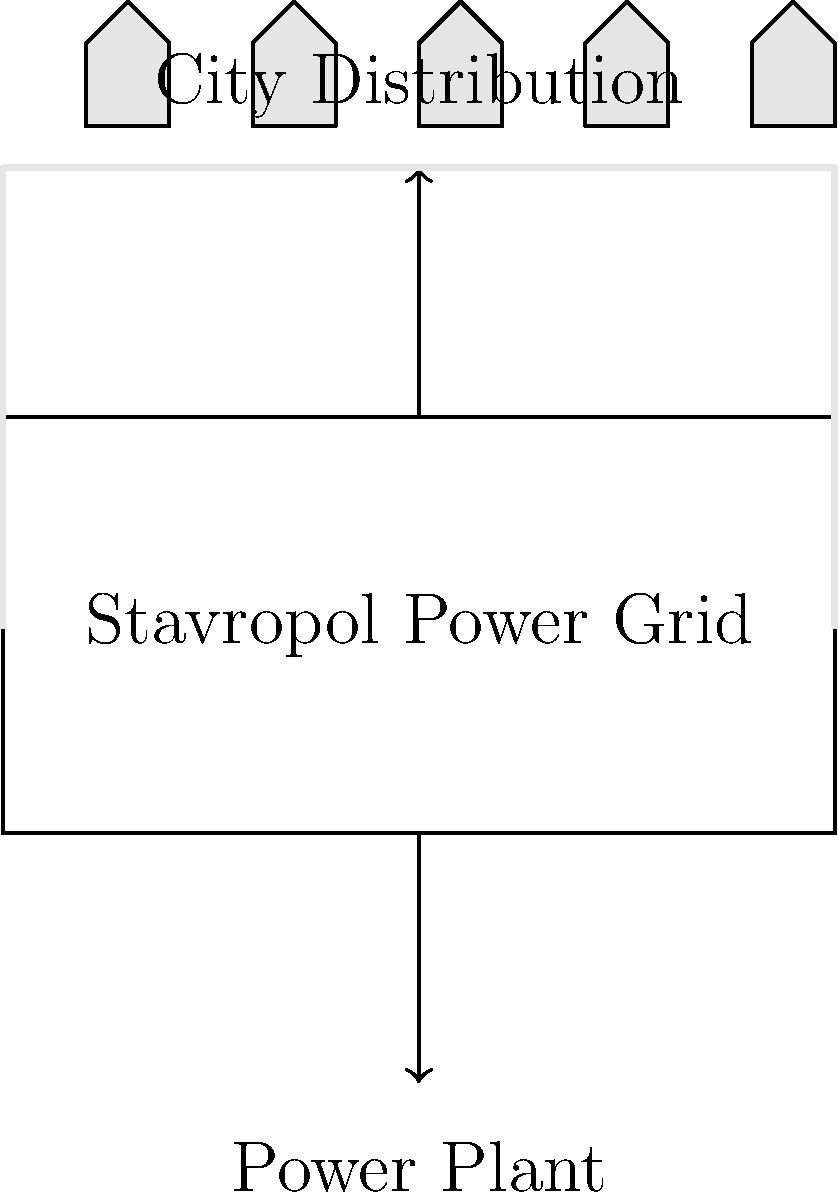In the simplified circuit diagram of Stavropol's power distribution system, what does the arrow pointing upwards from the "Stavropol Power Grid" represent? To answer this question, let's analyze the circuit diagram step by step:

1. The diagram shows a simplified representation of Stavropol's power distribution system.
2. At the bottom, we see a label "Power Plant", which is the source of electricity.
3. In the middle, there's a box labeled "Stavropol Power Grid", representing the city's main power infrastructure.
4. At the top, we see "City Distribution" with small houses, representing the end-users of electricity.
5. There are two arrows in the diagram:
   a) One pointing from the "Power Plant" to the "Stavropol Power Grid"
   b) Another pointing from the "Stavropol Power Grid" to the "City Distribution"
6. In electrical engineering, arrows typically represent the direction of current flow.
7. The arrow pointing upwards from the "Stavropol Power Grid" to "City Distribution" indicates the direction of power flow from the main grid to the end-users.

Therefore, the upward arrow represents the distribution of electrical power from the city's main grid to various parts of Stavropol for consumption by residents and businesses.
Answer: Power distribution to the city 